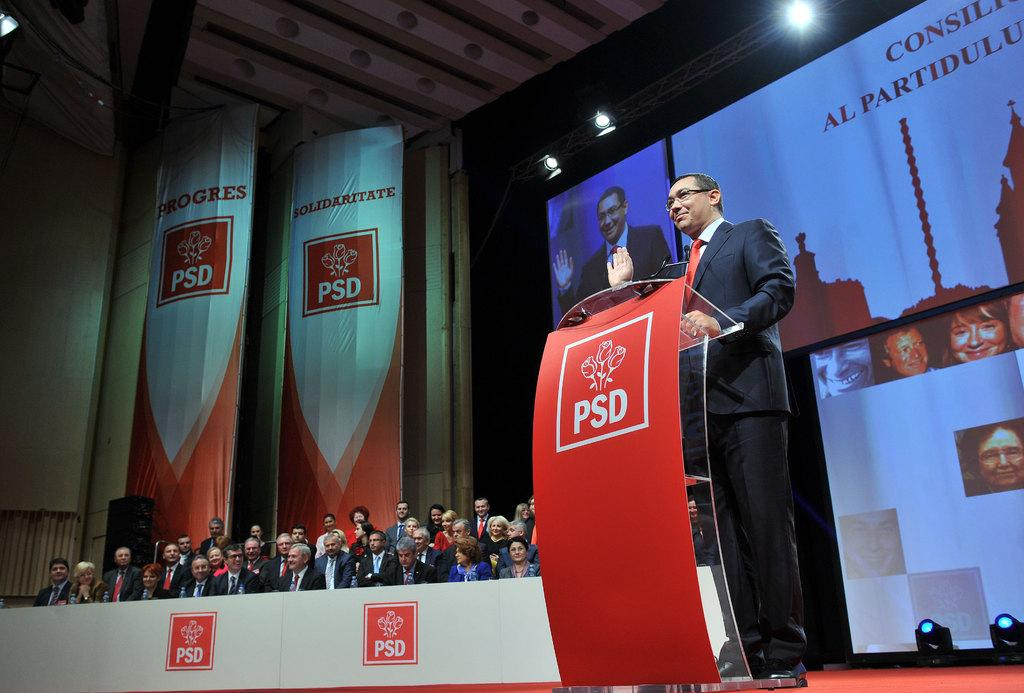What is the man doing on the right side of the image? The man is standing at a podium on the right side of the image. What can be seen in the background of the image? There are people sitting on chairs, hoardings, a wall, lights, and a screen visible in the background of the image. How are the people in the background positioned? The people in the background are sitting on chairs. Where is the sheep located in the image? There is no sheep present in the image. Is there a swing visible in the image? No, there is no swing present in the image. 